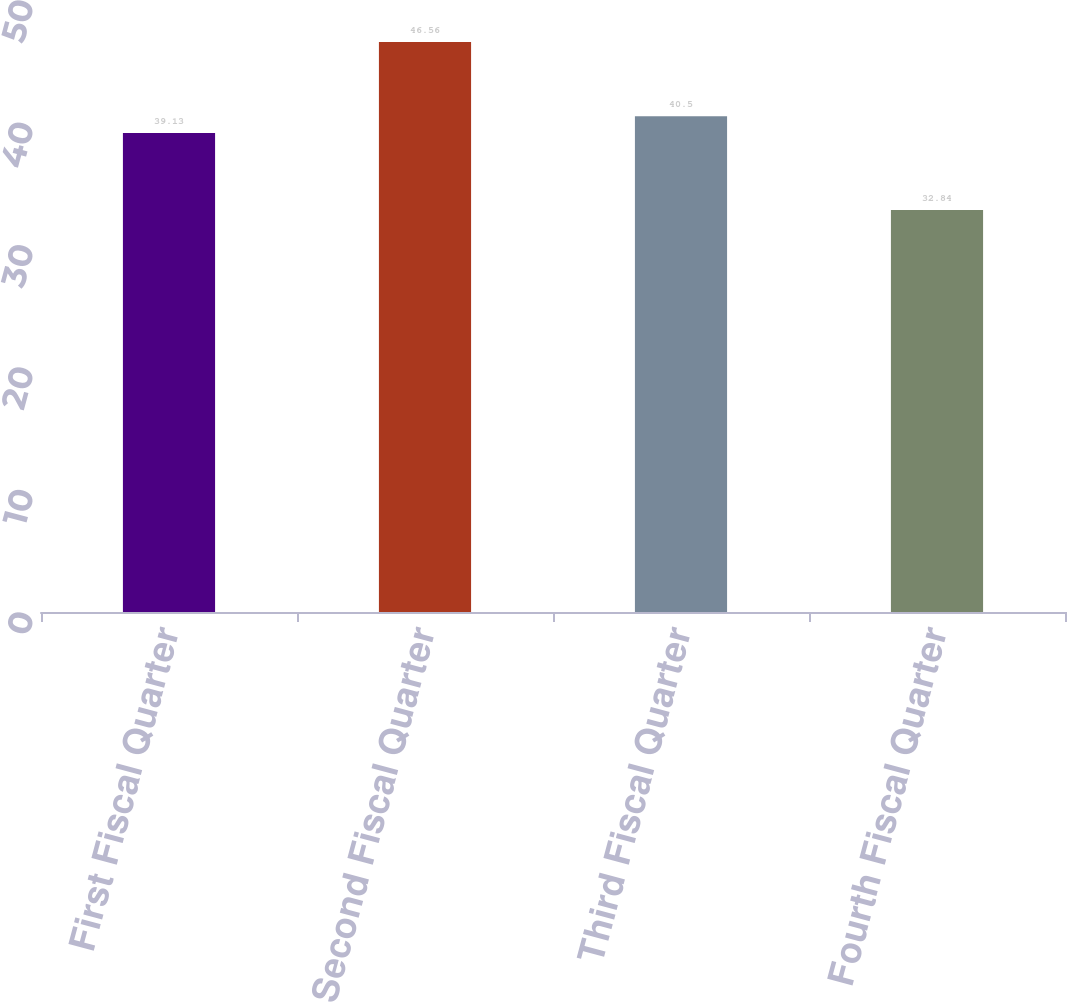<chart> <loc_0><loc_0><loc_500><loc_500><bar_chart><fcel>First Fiscal Quarter<fcel>Second Fiscal Quarter<fcel>Third Fiscal Quarter<fcel>Fourth Fiscal Quarter<nl><fcel>39.13<fcel>46.56<fcel>40.5<fcel>32.84<nl></chart> 